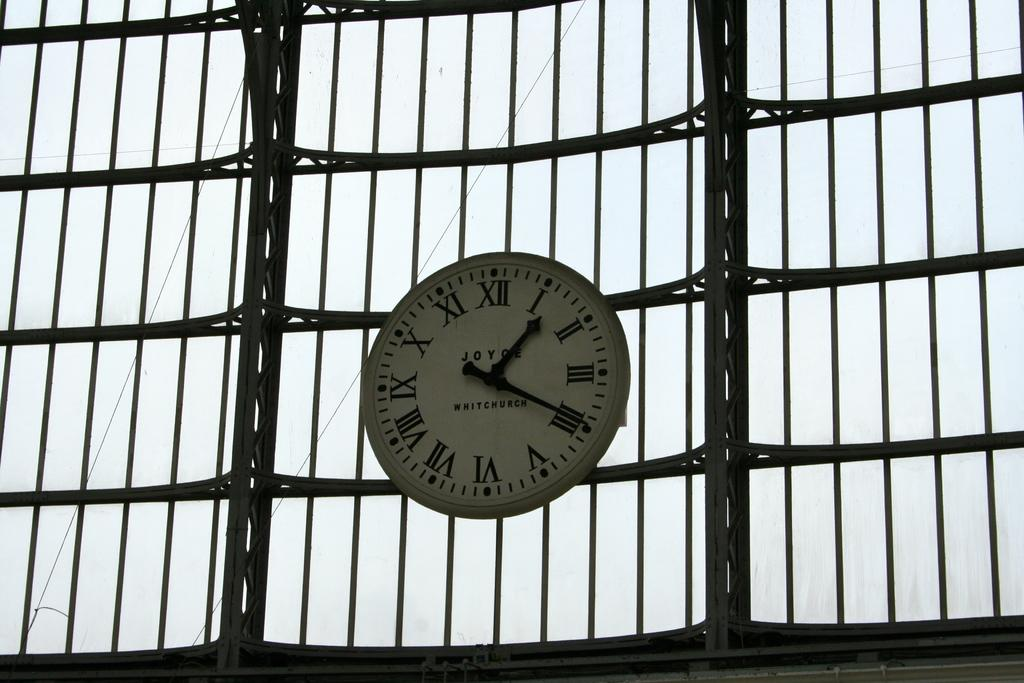Provide a one-sentence caption for the provided image. a clock that has many roman numerals on it. 